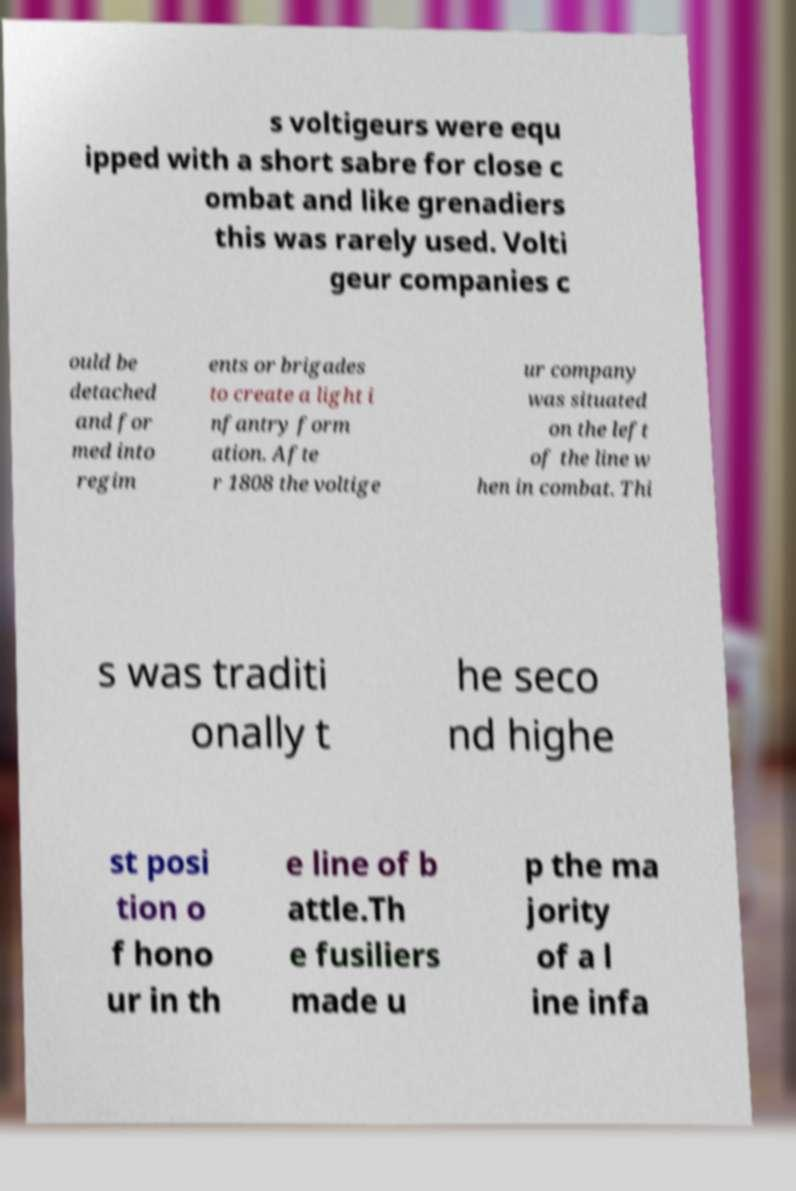Could you assist in decoding the text presented in this image and type it out clearly? s voltigeurs were equ ipped with a short sabre for close c ombat and like grenadiers this was rarely used. Volti geur companies c ould be detached and for med into regim ents or brigades to create a light i nfantry form ation. Afte r 1808 the voltige ur company was situated on the left of the line w hen in combat. Thi s was traditi onally t he seco nd highe st posi tion o f hono ur in th e line of b attle.Th e fusiliers made u p the ma jority of a l ine infa 